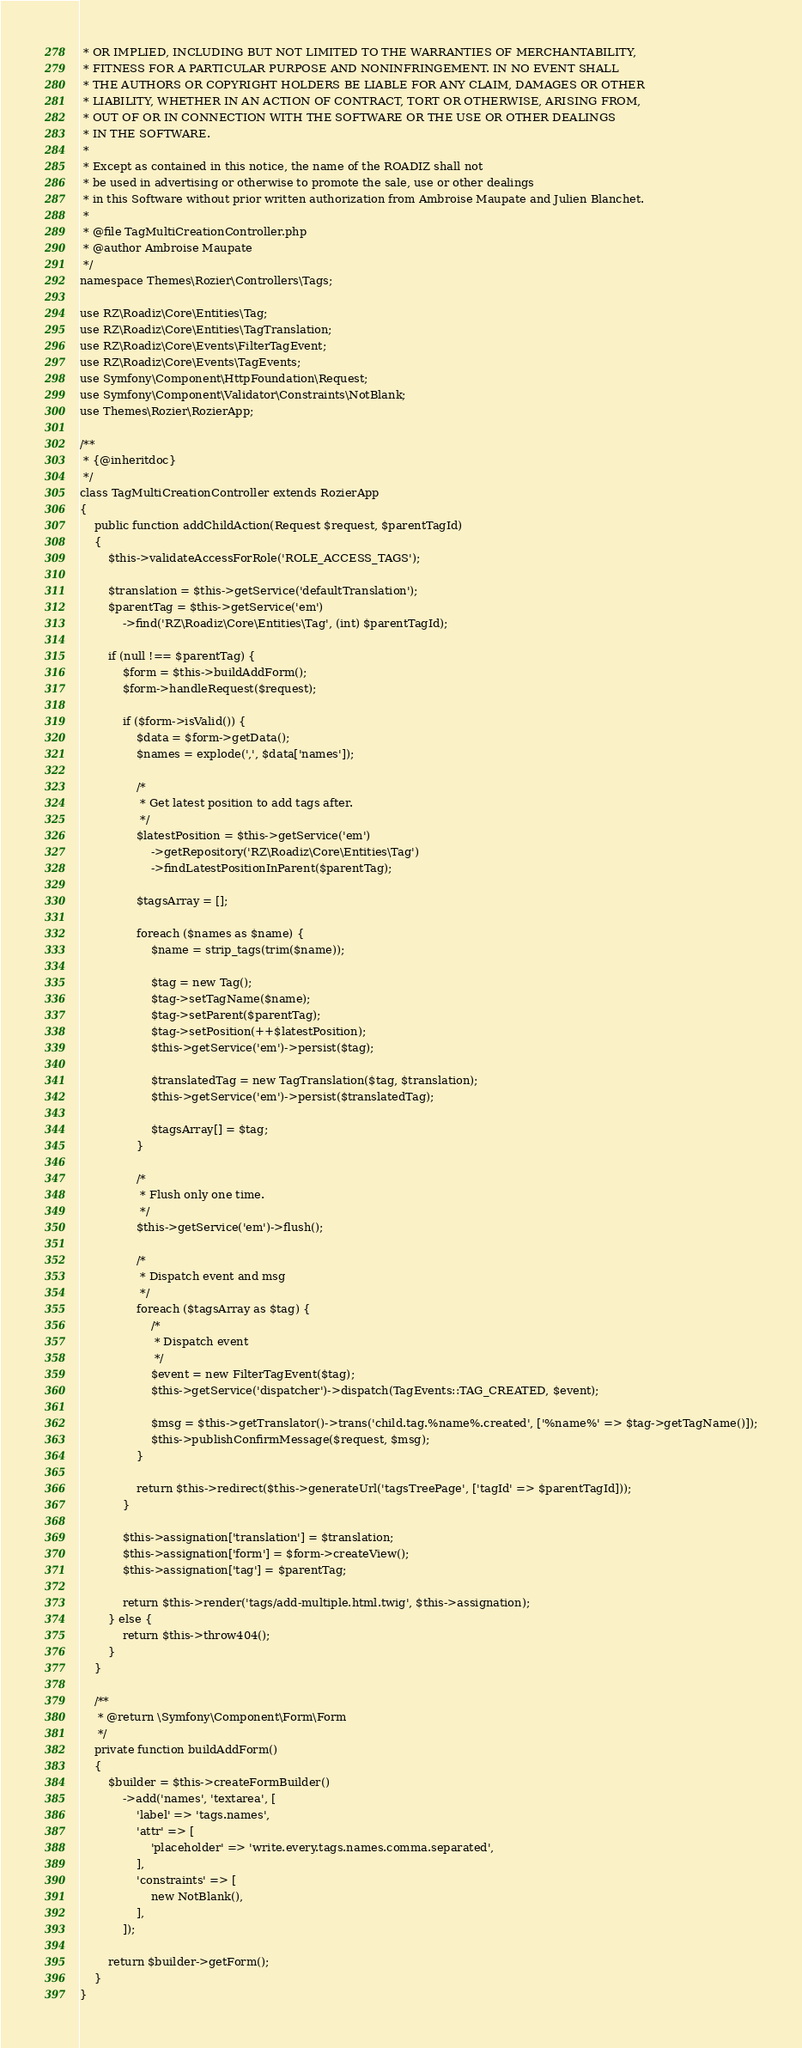Convert code to text. <code><loc_0><loc_0><loc_500><loc_500><_PHP_> * OR IMPLIED, INCLUDING BUT NOT LIMITED TO THE WARRANTIES OF MERCHANTABILITY,
 * FITNESS FOR A PARTICULAR PURPOSE AND NONINFRINGEMENT. IN NO EVENT SHALL
 * THE AUTHORS OR COPYRIGHT HOLDERS BE LIABLE FOR ANY CLAIM, DAMAGES OR OTHER
 * LIABILITY, WHETHER IN AN ACTION OF CONTRACT, TORT OR OTHERWISE, ARISING FROM,
 * OUT OF OR IN CONNECTION WITH THE SOFTWARE OR THE USE OR OTHER DEALINGS
 * IN THE SOFTWARE.
 *
 * Except as contained in this notice, the name of the ROADIZ shall not
 * be used in advertising or otherwise to promote the sale, use or other dealings
 * in this Software without prior written authorization from Ambroise Maupate and Julien Blanchet.
 *
 * @file TagMultiCreationController.php
 * @author Ambroise Maupate
 */
namespace Themes\Rozier\Controllers\Tags;

use RZ\Roadiz\Core\Entities\Tag;
use RZ\Roadiz\Core\Entities\TagTranslation;
use RZ\Roadiz\Core\Events\FilterTagEvent;
use RZ\Roadiz\Core\Events\TagEvents;
use Symfony\Component\HttpFoundation\Request;
use Symfony\Component\Validator\Constraints\NotBlank;
use Themes\Rozier\RozierApp;

/**
 * {@inheritdoc}
 */
class TagMultiCreationController extends RozierApp
{
    public function addChildAction(Request $request, $parentTagId)
    {
        $this->validateAccessForRole('ROLE_ACCESS_TAGS');

        $translation = $this->getService('defaultTranslation');
        $parentTag = $this->getService('em')
            ->find('RZ\Roadiz\Core\Entities\Tag', (int) $parentTagId);

        if (null !== $parentTag) {
            $form = $this->buildAddForm();
            $form->handleRequest($request);

            if ($form->isValid()) {
                $data = $form->getData();
                $names = explode(',', $data['names']);

                /*
                 * Get latest position to add tags after.
                 */
                $latestPosition = $this->getService('em')
                    ->getRepository('RZ\Roadiz\Core\Entities\Tag')
                    ->findLatestPositionInParent($parentTag);

                $tagsArray = [];

                foreach ($names as $name) {
                    $name = strip_tags(trim($name));

                    $tag = new Tag();
                    $tag->setTagName($name);
                    $tag->setParent($parentTag);
                    $tag->setPosition(++$latestPosition);
                    $this->getService('em')->persist($tag);

                    $translatedTag = new TagTranslation($tag, $translation);
                    $this->getService('em')->persist($translatedTag);

                    $tagsArray[] = $tag;
                }

                /*
                 * Flush only one time.
                 */
                $this->getService('em')->flush();

                /*
                 * Dispatch event and msg
                 */
                foreach ($tagsArray as $tag) {
                    /*
                     * Dispatch event
                     */
                    $event = new FilterTagEvent($tag);
                    $this->getService('dispatcher')->dispatch(TagEvents::TAG_CREATED, $event);

                    $msg = $this->getTranslator()->trans('child.tag.%name%.created', ['%name%' => $tag->getTagName()]);
                    $this->publishConfirmMessage($request, $msg);
                }

                return $this->redirect($this->generateUrl('tagsTreePage', ['tagId' => $parentTagId]));
            }

            $this->assignation['translation'] = $translation;
            $this->assignation['form'] = $form->createView();
            $this->assignation['tag'] = $parentTag;

            return $this->render('tags/add-multiple.html.twig', $this->assignation);
        } else {
            return $this->throw404();
        }
    }

    /**
     * @return \Symfony\Component\Form\Form
     */
    private function buildAddForm()
    {
        $builder = $this->createFormBuilder()
            ->add('names', 'textarea', [
                'label' => 'tags.names',
                'attr' => [
                    'placeholder' => 'write.every.tags.names.comma.separated',
                ],
                'constraints' => [
                    new NotBlank(),
                ],
            ]);

        return $builder->getForm();
    }
}
</code> 